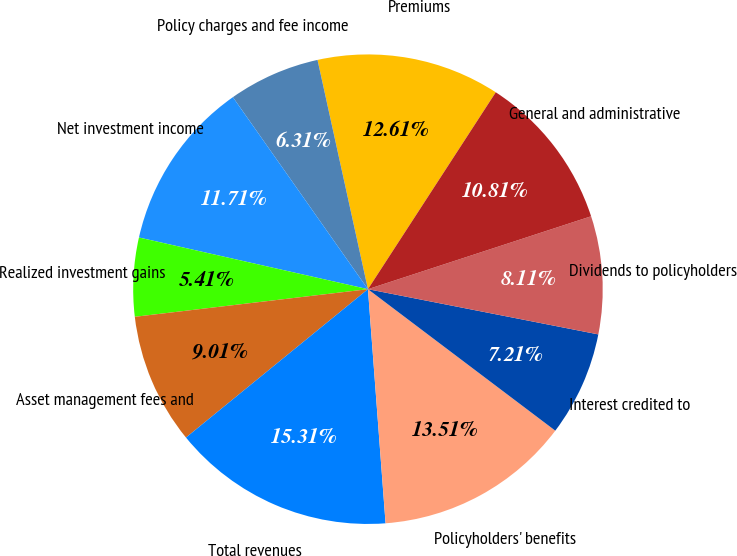<chart> <loc_0><loc_0><loc_500><loc_500><pie_chart><fcel>Premiums<fcel>Policy charges and fee income<fcel>Net investment income<fcel>Realized investment gains<fcel>Asset management fees and<fcel>Total revenues<fcel>Policyholders' benefits<fcel>Interest credited to<fcel>Dividends to policyholders<fcel>General and administrative<nl><fcel>12.61%<fcel>6.31%<fcel>11.71%<fcel>5.41%<fcel>9.01%<fcel>15.31%<fcel>13.51%<fcel>7.21%<fcel>8.11%<fcel>10.81%<nl></chart> 